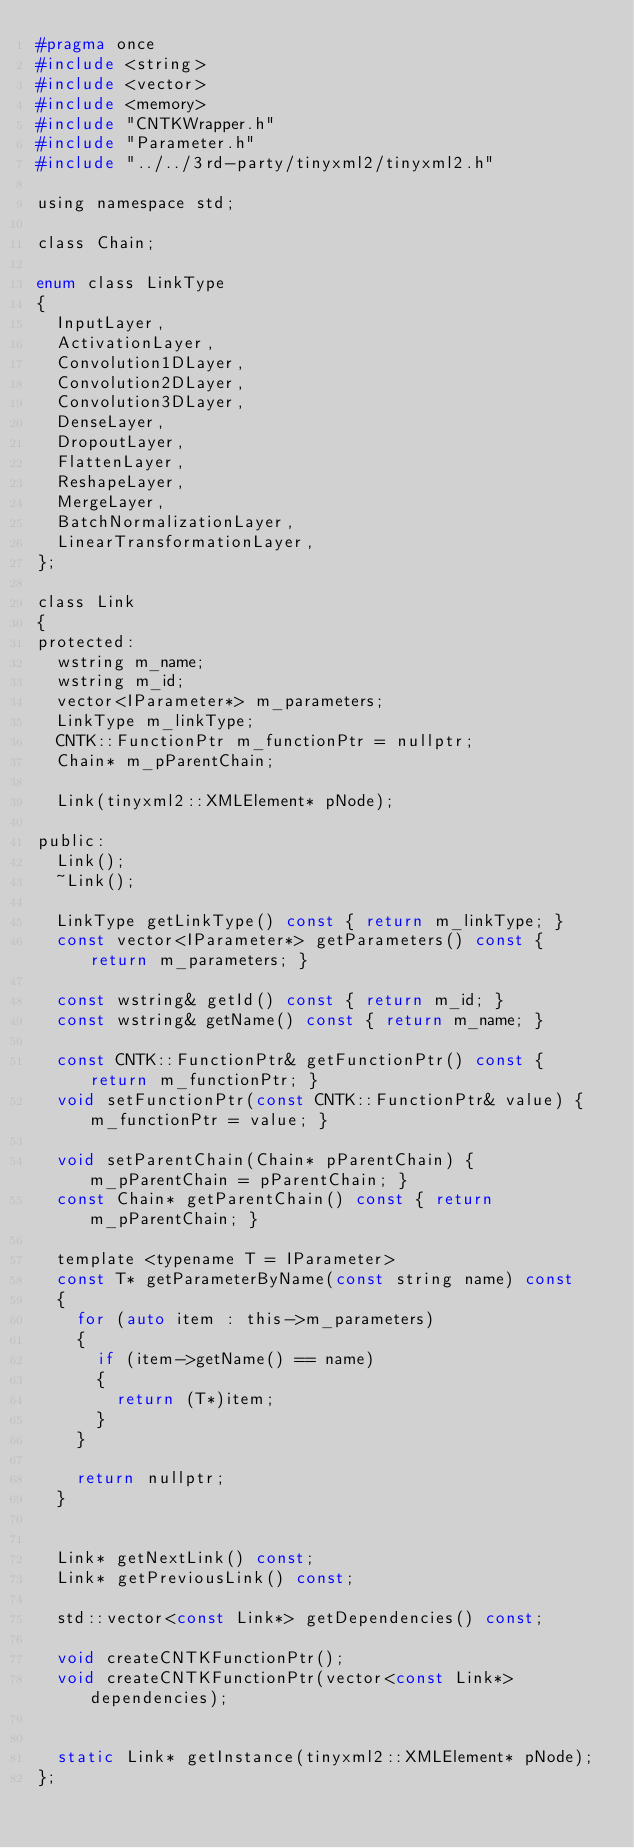<code> <loc_0><loc_0><loc_500><loc_500><_C_>#pragma once
#include <string>
#include <vector>
#include <memory>
#include "CNTKWrapper.h"
#include "Parameter.h"
#include "../../3rd-party/tinyxml2/tinyxml2.h"

using namespace std;

class Chain;

enum class LinkType
{
	InputLayer,
	ActivationLayer,
	Convolution1DLayer,
	Convolution2DLayer,
	Convolution3DLayer,
	DenseLayer,
	DropoutLayer,
	FlattenLayer,
	ReshapeLayer,
	MergeLayer,
	BatchNormalizationLayer,
	LinearTransformationLayer,
};

class Link
{
protected:
	wstring m_name;
	wstring m_id;
	vector<IParameter*> m_parameters;
	LinkType m_linkType;
	CNTK::FunctionPtr m_functionPtr = nullptr;
	Chain* m_pParentChain;

	Link(tinyxml2::XMLElement* pNode);	

public:
	Link();
	~Link();

	LinkType getLinkType() const { return m_linkType; }
	const vector<IParameter*> getParameters() const { return m_parameters; }

	const wstring& getId() const { return m_id; }
	const wstring& getName() const { return m_name; }

	const CNTK::FunctionPtr& getFunctionPtr() const { return m_functionPtr; }
	void setFunctionPtr(const CNTK::FunctionPtr& value) { m_functionPtr = value; }

	void setParentChain(Chain* pParentChain) { m_pParentChain = pParentChain; }
	const Chain* getParentChain() const { return m_pParentChain; }

	template <typename T = IParameter>
	const T* getParameterByName(const string name) const
	{
		for (auto item : this->m_parameters)
		{
			if (item->getName() == name)
			{
				return (T*)item;
			}
		}

		return nullptr;
	}


	Link* getNextLink() const;
	Link* getPreviousLink() const;

	std::vector<const Link*> getDependencies() const;

	void createCNTKFunctionPtr();
	void createCNTKFunctionPtr(vector<const Link*> dependencies);


	static Link* getInstance(tinyxml2::XMLElement* pNode);
};</code> 